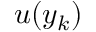Convert formula to latex. <formula><loc_0><loc_0><loc_500><loc_500>u ( y _ { k } )</formula> 